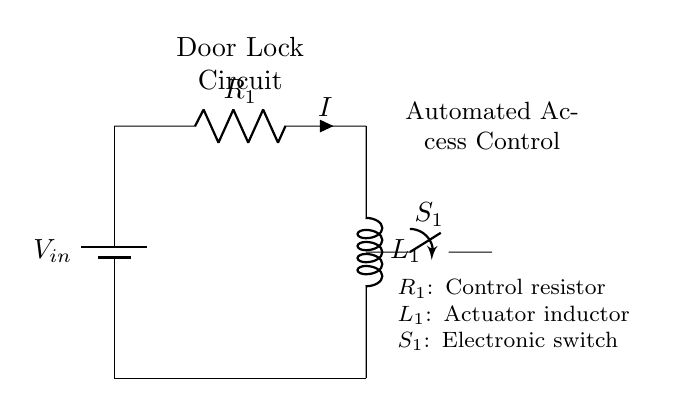What type of power source is used in this circuit? The circuit uses a battery as the power source, indicated by the symbol for a battery labeled V_in at the top left corner.
Answer: battery What is the role of the resistor in this circuit? The resistor R_1 controls the current I flowing through the circuit. It limits the amount of current that can pass through, which is important for protecting the other components.
Answer: controls current What components are depicted in the circuit? The circuit contains three main components: a battery (V_in), a resistor (R_1), and an inductor (L_1), plus a switch (S_1). Each component plays a crucial role in the function of the automated door lock mechanism.
Answer: battery, resistor, inductor, switch What happens when switch S_1 is closed? Closing the switch S_1 allows current I to flow through the inductor L_1, which activates the door lock mechanism. This action typically engages the locking mechanism to secure the door, demonstrating how the circuit functions in practice.
Answer: activates lock Why is an inductor used in this circuit? The inductor L_1 serves to store energy in a magnetic field when current flows through it. This is essential in circuits controlling something like an automated door lock, where a quick response may be needed when the door is activated. Additionally, the inductor can also help reduce current spikes and provide smoother operation.
Answer: stores energy What does the switch S_1 represent? The switch S_1 represents an electronic means to control the circuit, functioning as a mechanism to either allow or stop the flow of current to the inductor. This is essential in automated systems for controlling access securely.
Answer: electronic switch 